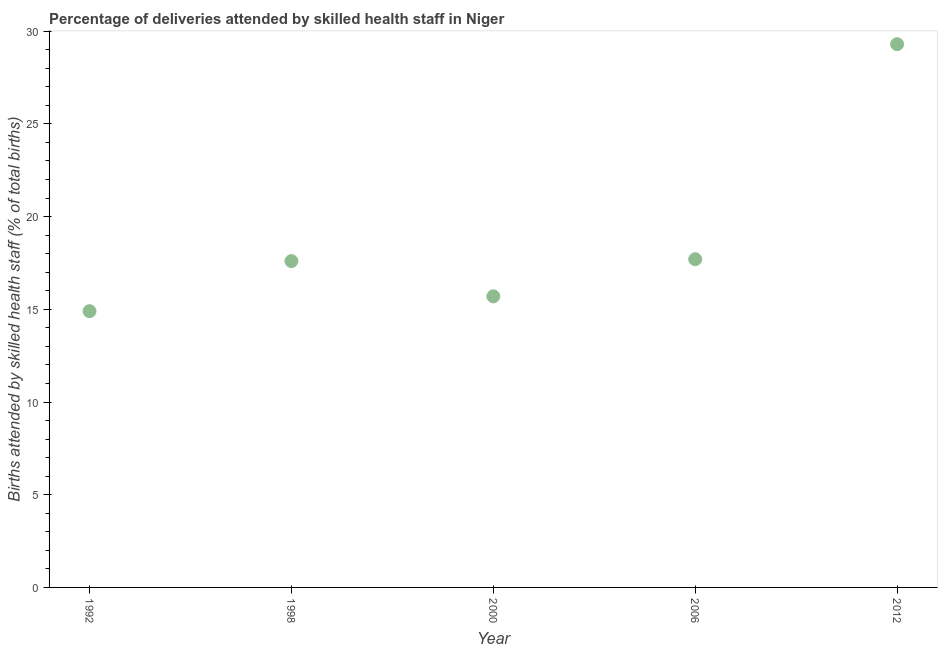Across all years, what is the maximum number of births attended by skilled health staff?
Provide a short and direct response. 29.3. In which year was the number of births attended by skilled health staff maximum?
Provide a succinct answer. 2012. In which year was the number of births attended by skilled health staff minimum?
Provide a short and direct response. 1992. What is the sum of the number of births attended by skilled health staff?
Offer a very short reply. 95.2. What is the difference between the number of births attended by skilled health staff in 2000 and 2012?
Your answer should be very brief. -13.6. What is the average number of births attended by skilled health staff per year?
Your response must be concise. 19.04. What is the median number of births attended by skilled health staff?
Make the answer very short. 17.6. Do a majority of the years between 2000 and 1992 (inclusive) have number of births attended by skilled health staff greater than 29 %?
Your answer should be very brief. No. What is the ratio of the number of births attended by skilled health staff in 1998 to that in 2006?
Keep it short and to the point. 0.99. Is the number of births attended by skilled health staff in 1998 less than that in 2012?
Keep it short and to the point. Yes. Is the difference between the number of births attended by skilled health staff in 1992 and 1998 greater than the difference between any two years?
Make the answer very short. No. What is the difference between the highest and the second highest number of births attended by skilled health staff?
Keep it short and to the point. 11.6. Is the sum of the number of births attended by skilled health staff in 1998 and 2012 greater than the maximum number of births attended by skilled health staff across all years?
Give a very brief answer. Yes. What is the difference between the highest and the lowest number of births attended by skilled health staff?
Ensure brevity in your answer.  14.4. In how many years, is the number of births attended by skilled health staff greater than the average number of births attended by skilled health staff taken over all years?
Offer a terse response. 1. Does the number of births attended by skilled health staff monotonically increase over the years?
Give a very brief answer. No. Does the graph contain grids?
Your answer should be compact. No. What is the title of the graph?
Offer a very short reply. Percentage of deliveries attended by skilled health staff in Niger. What is the label or title of the X-axis?
Your response must be concise. Year. What is the label or title of the Y-axis?
Your response must be concise. Births attended by skilled health staff (% of total births). What is the Births attended by skilled health staff (% of total births) in 2000?
Offer a very short reply. 15.7. What is the Births attended by skilled health staff (% of total births) in 2006?
Ensure brevity in your answer.  17.7. What is the Births attended by skilled health staff (% of total births) in 2012?
Give a very brief answer. 29.3. What is the difference between the Births attended by skilled health staff (% of total births) in 1992 and 2006?
Your response must be concise. -2.8. What is the difference between the Births attended by skilled health staff (% of total births) in 1992 and 2012?
Provide a succinct answer. -14.4. What is the difference between the Births attended by skilled health staff (% of total births) in 1998 and 2000?
Give a very brief answer. 1.9. What is the difference between the Births attended by skilled health staff (% of total births) in 1998 and 2012?
Your answer should be very brief. -11.7. What is the difference between the Births attended by skilled health staff (% of total births) in 2000 and 2012?
Your response must be concise. -13.6. What is the ratio of the Births attended by skilled health staff (% of total births) in 1992 to that in 1998?
Ensure brevity in your answer.  0.85. What is the ratio of the Births attended by skilled health staff (% of total births) in 1992 to that in 2000?
Make the answer very short. 0.95. What is the ratio of the Births attended by skilled health staff (% of total births) in 1992 to that in 2006?
Your response must be concise. 0.84. What is the ratio of the Births attended by skilled health staff (% of total births) in 1992 to that in 2012?
Give a very brief answer. 0.51. What is the ratio of the Births attended by skilled health staff (% of total births) in 1998 to that in 2000?
Make the answer very short. 1.12. What is the ratio of the Births attended by skilled health staff (% of total births) in 1998 to that in 2012?
Ensure brevity in your answer.  0.6. What is the ratio of the Births attended by skilled health staff (% of total births) in 2000 to that in 2006?
Ensure brevity in your answer.  0.89. What is the ratio of the Births attended by skilled health staff (% of total births) in 2000 to that in 2012?
Make the answer very short. 0.54. What is the ratio of the Births attended by skilled health staff (% of total births) in 2006 to that in 2012?
Give a very brief answer. 0.6. 